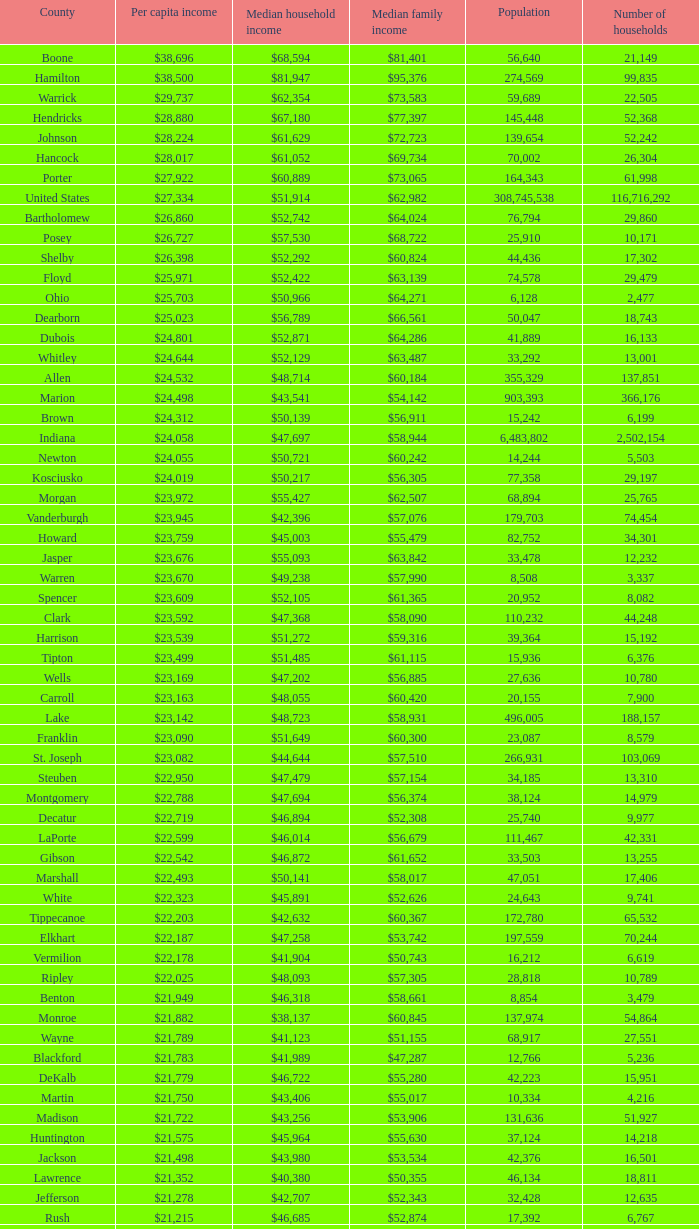What County has a Median household income of $46,872? Gibson. 